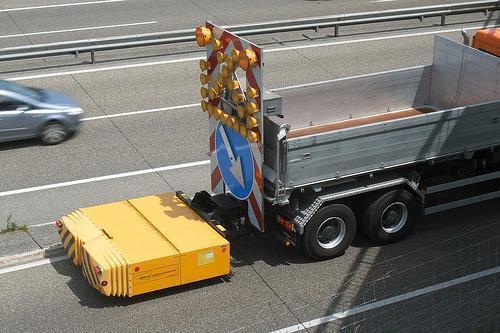How many cars are visible?
Give a very brief answer. 2. 